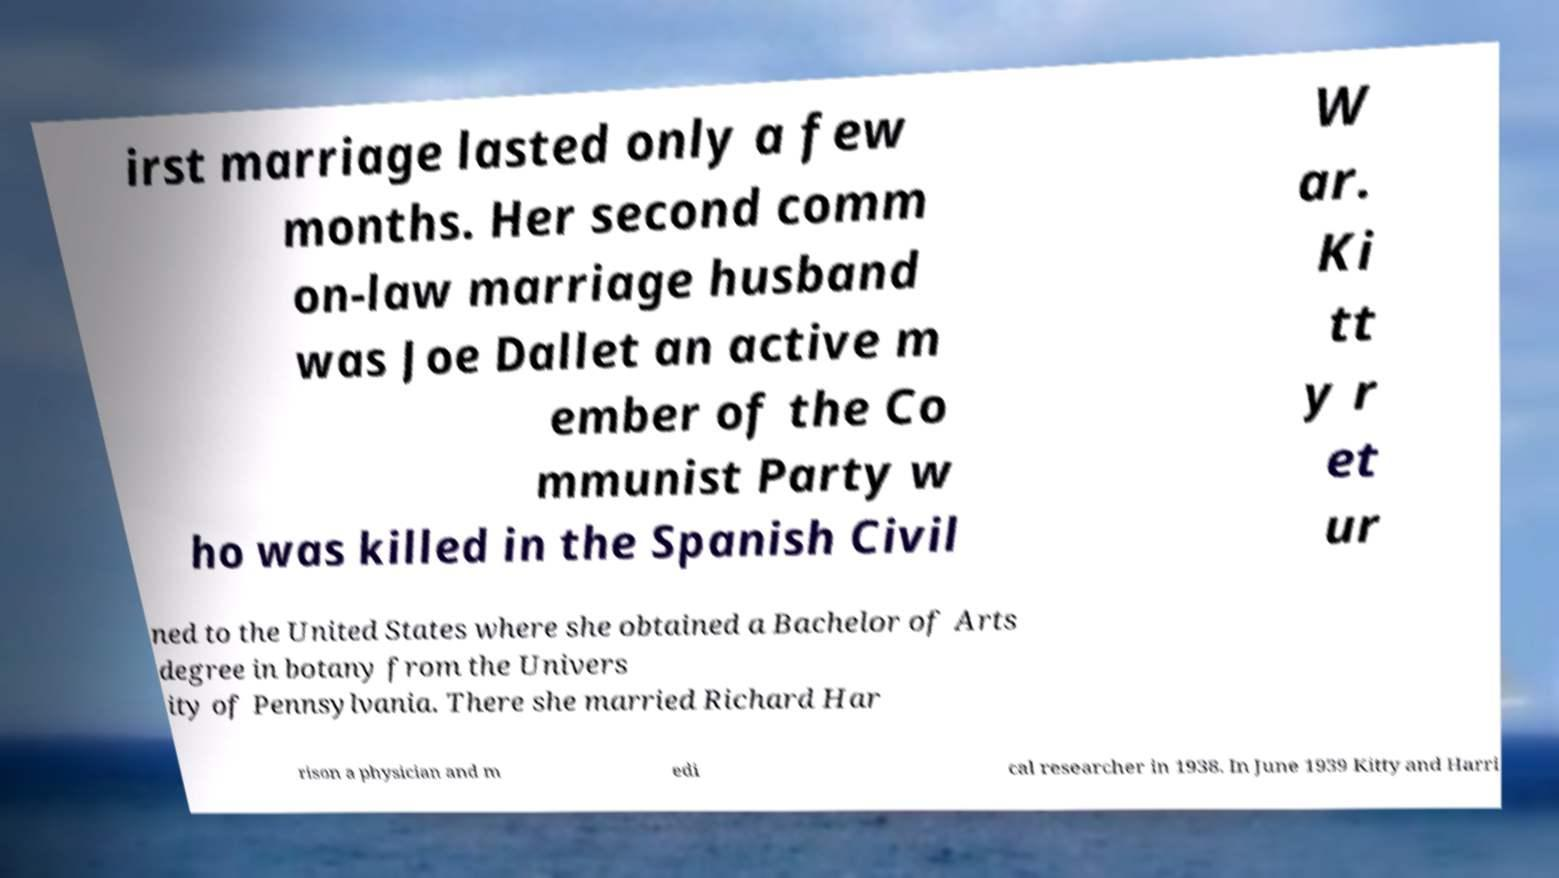I need the written content from this picture converted into text. Can you do that? irst marriage lasted only a few months. Her second comm on-law marriage husband was Joe Dallet an active m ember of the Co mmunist Party w ho was killed in the Spanish Civil W ar. Ki tt y r et ur ned to the United States where she obtained a Bachelor of Arts degree in botany from the Univers ity of Pennsylvania. There she married Richard Har rison a physician and m edi cal researcher in 1938. In June 1939 Kitty and Harri 